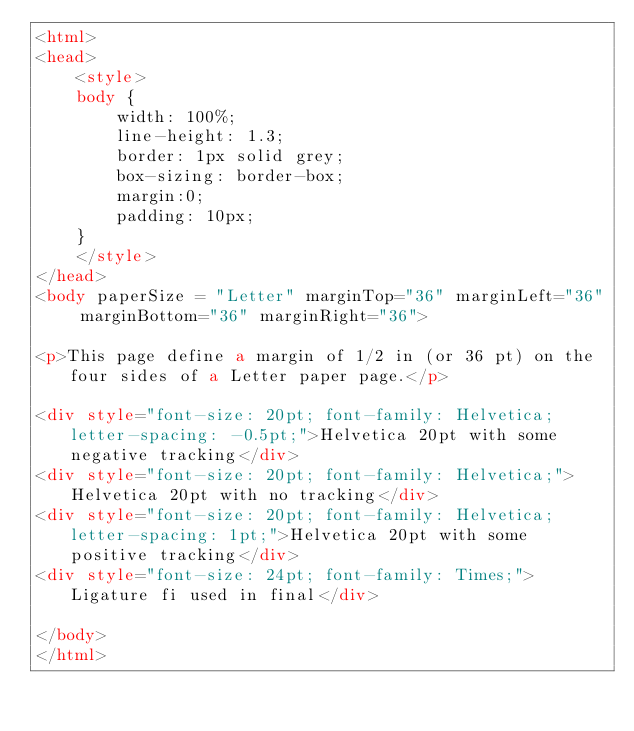<code> <loc_0><loc_0><loc_500><loc_500><_HTML_><html>
<head>
	<style>
	body {
		width: 100%;
		line-height: 1.3;
		border: 1px solid grey;
		box-sizing: border-box; 
		margin:0;
		padding: 10px;
	}
	</style>
</head>
<body paperSize = "Letter" marginTop="36" marginLeft="36" marginBottom="36" marginRight="36">

<p>This page define a margin of 1/2 in (or 36 pt) on the four sides of a Letter paper page.</p>

<div style="font-size: 20pt; font-family: Helvetica;  letter-spacing: -0.5pt;">Helvetica 20pt with some negative tracking</div>
<div style="font-size: 20pt; font-family: Helvetica;">Helvetica 20pt with no tracking</div>
<div style="font-size: 20pt; font-family: Helvetica;  letter-spacing: 1pt;">Helvetica 20pt with some positive tracking</div>
<div style="font-size: 24pt; font-family: Times;">Ligature fi used in final</div>

</body>
</html></code> 